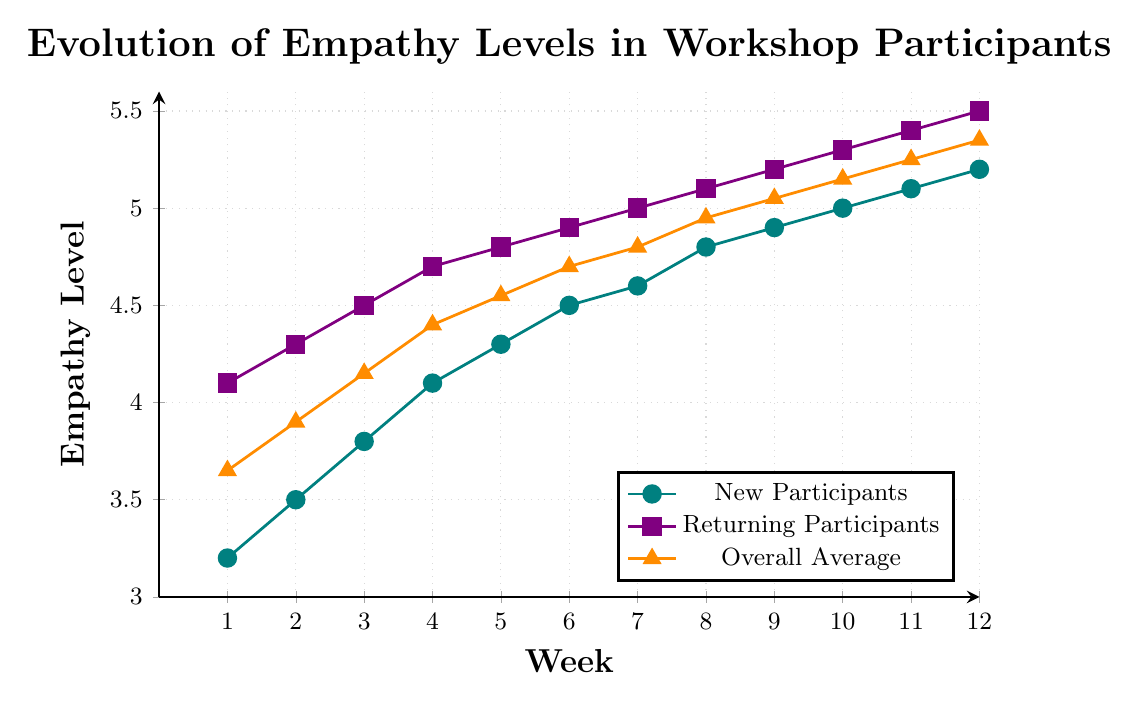What's the empathy level of new participants at Week 6? The figure shows that the empathy level of new participants is marked with circles. At Week 6, the new participants' empathy level is at 4.5.
Answer: 4.5 What is the difference in empathy levels between new and returning participants at Week 3? At Week 3, the empathy level for new participants is 3.8 and for returning participants, it's 4.5. The difference is 4.5 - 3.8.
Answer: 0.7 How does the overall average empathy level change from Week 1 to Week 12? The overall average empathy level starts at 3.65 at Week 1 and increases to 5.35 by Week 12. The change is calculated as 5.35 - 3.65.
Answer: 1.7 Which week shows the highest empathy level for returning participants, and what is the value? The returning participants' empathy levels are shown to increase steadily each week, reaching the highest value at Week 12, which is 5.5.
Answer: Week 12, 5.5 Are there any weeks where the empathy levels of new participants and returning participants are the same? By examining the lines representing new and returning participants, we see that empathy levels never overlap or are the same at any given week.
Answer: No What is the average empathy level increase per week for new participants? The empathy level starts at 3.2 in Week 1 and reaches 5.2 in Week 12. The total increase is 5.2 - 3.2, which is 2. The number of weeks is 12-1, that is 11 weeks. Therefore, the average increase per week is 2/11.
Answer: 0.18 Compare the empathy levels of new participants and the overall average at Week 10? At Week 10, the empathy level for new participants is 5.0, and the overall average is 5.15. Comparing these values, 5.0 is less than 5.15.
Answer: New: 5.0, Overall average: 5.15 By how much does the overall average empathy level increase from Week 4 to Week 8? At Week 4, the overall average is 4.4, and at Week 8, it is 4.95. The increase is calculated as 4.95 - 4.4.
Answer: 0.55 What is the overall average empathy level at the halfway point (Week 6)? The overall average empathy levels are shown at the triangular points on the line. At Week 6, the overall average is 4.7.
Answer: 4.7 What color is used to represent the empathy levels of returning participants? The empathy levels of returning participants are represented with purple-colored squares in the chart.
Answer: Purple 